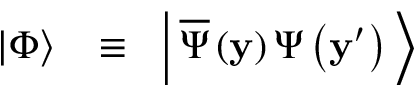Convert formula to latex. <formula><loc_0><loc_0><loc_500><loc_500>\begin{array} { r l r } { \left | \Phi \right \rangle \, } & \equiv } & { \, \left | \, { \overline { \Psi } \left ( { y } \right ) \Psi \left ( { { { y } ^ { \prime } } } \right ) } \, \right \rangle } \end{array}</formula> 